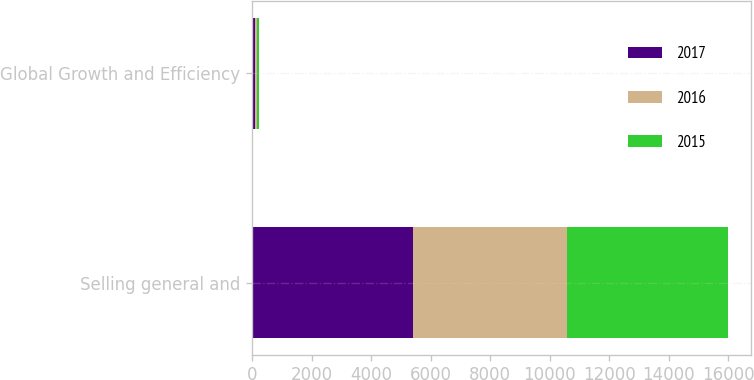Convert chart to OTSL. <chart><loc_0><loc_0><loc_500><loc_500><stacked_bar_chart><ecel><fcel>Selling general and<fcel>Global Growth and Efficiency<nl><fcel>2017<fcel>5408<fcel>89<nl><fcel>2016<fcel>5172<fcel>77<nl><fcel>2015<fcel>5400<fcel>64<nl></chart> 